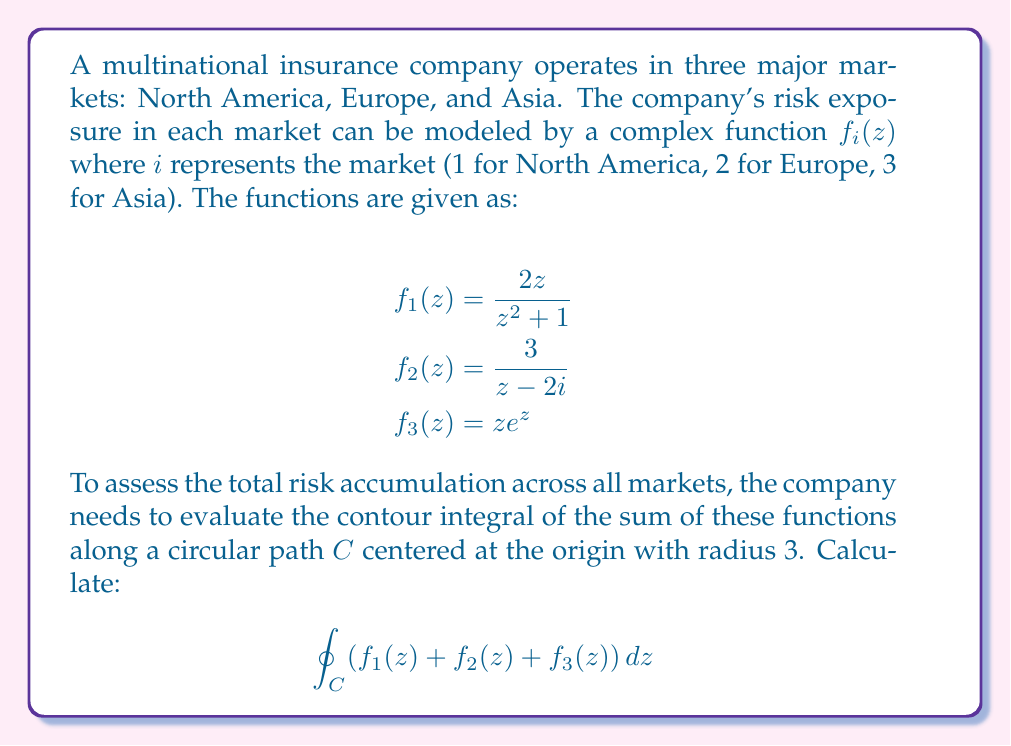What is the answer to this math problem? Let's approach this problem step by step:

1) First, we need to evaluate each function separately using the residue theorem.

2) For $f_1(z) = \frac{2z}{z^2 + 1}$:
   - This function has simple poles at $z = \pm i$
   - Only $z = i$ is inside the contour
   - Residue at $z = i$: $\lim_{z \to i} (z-i)\frac{2z}{z^2+1} = i$
   
3) For $f_2(z) = \frac{3}{z-2i}$:
   - This function has a simple pole at $z = 2i$
   - The pole is inside the contour
   - Residue at $z = 2i$: $\lim_{z \to 2i} (z-2i)\frac{3}{z-2i} = 3$

4) For $f_3(z) = ze^z$:
   - This function is entire (no poles)
   - By Cauchy's theorem, its integral around a closed contour is 0

5) Now, we can apply the residue theorem:
   $$\oint_C (f_1(z) + f_2(z) + f_3(z)) dz = 2\pi i(\text{sum of residues})$$
   $$= 2\pi i(i + 3 + 0) = 2\pi i(3+i)$$

6) To express this in standard form:
   $$2\pi i(3+i) = 2\pi(3i - 1) = -2\pi + 6\pi i$$
Answer: $-2\pi + 6\pi i$ 